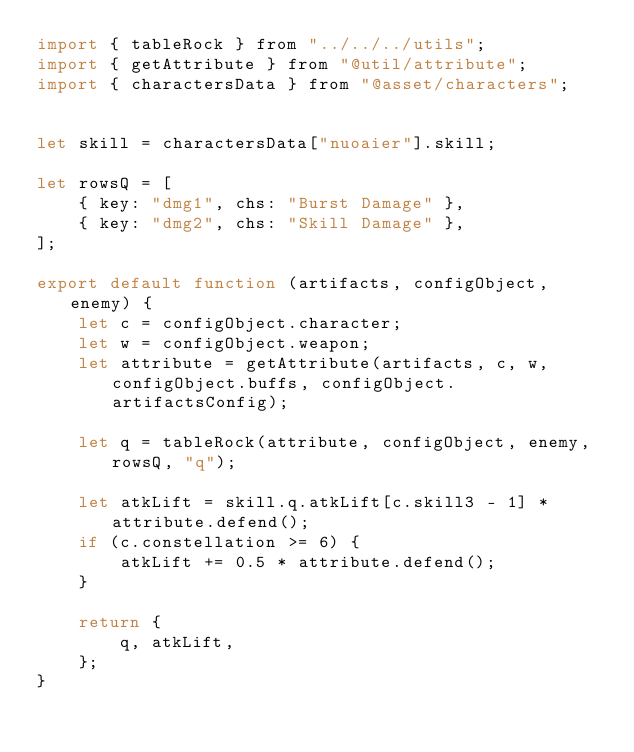<code> <loc_0><loc_0><loc_500><loc_500><_JavaScript_>import { tableRock } from "../../../utils";
import { getAttribute } from "@util/attribute";
import { charactersData } from "@asset/characters";


let skill = charactersData["nuoaier"].skill;

let rowsQ = [
    { key: "dmg1", chs: "Burst Damage" },
    { key: "dmg2", chs: "Skill Damage" },
];

export default function (artifacts, configObject, enemy) {
    let c = configObject.character;
    let w = configObject.weapon;
    let attribute = getAttribute(artifacts, c, w, configObject.buffs, configObject.artifactsConfig);

    let q = tableRock(attribute, configObject, enemy, rowsQ, "q");

    let atkLift = skill.q.atkLift[c.skill3 - 1] * attribute.defend();
    if (c.constellation >= 6) {
        atkLift += 0.5 * attribute.defend();
    }

    return {
        q, atkLift,
    };
}</code> 